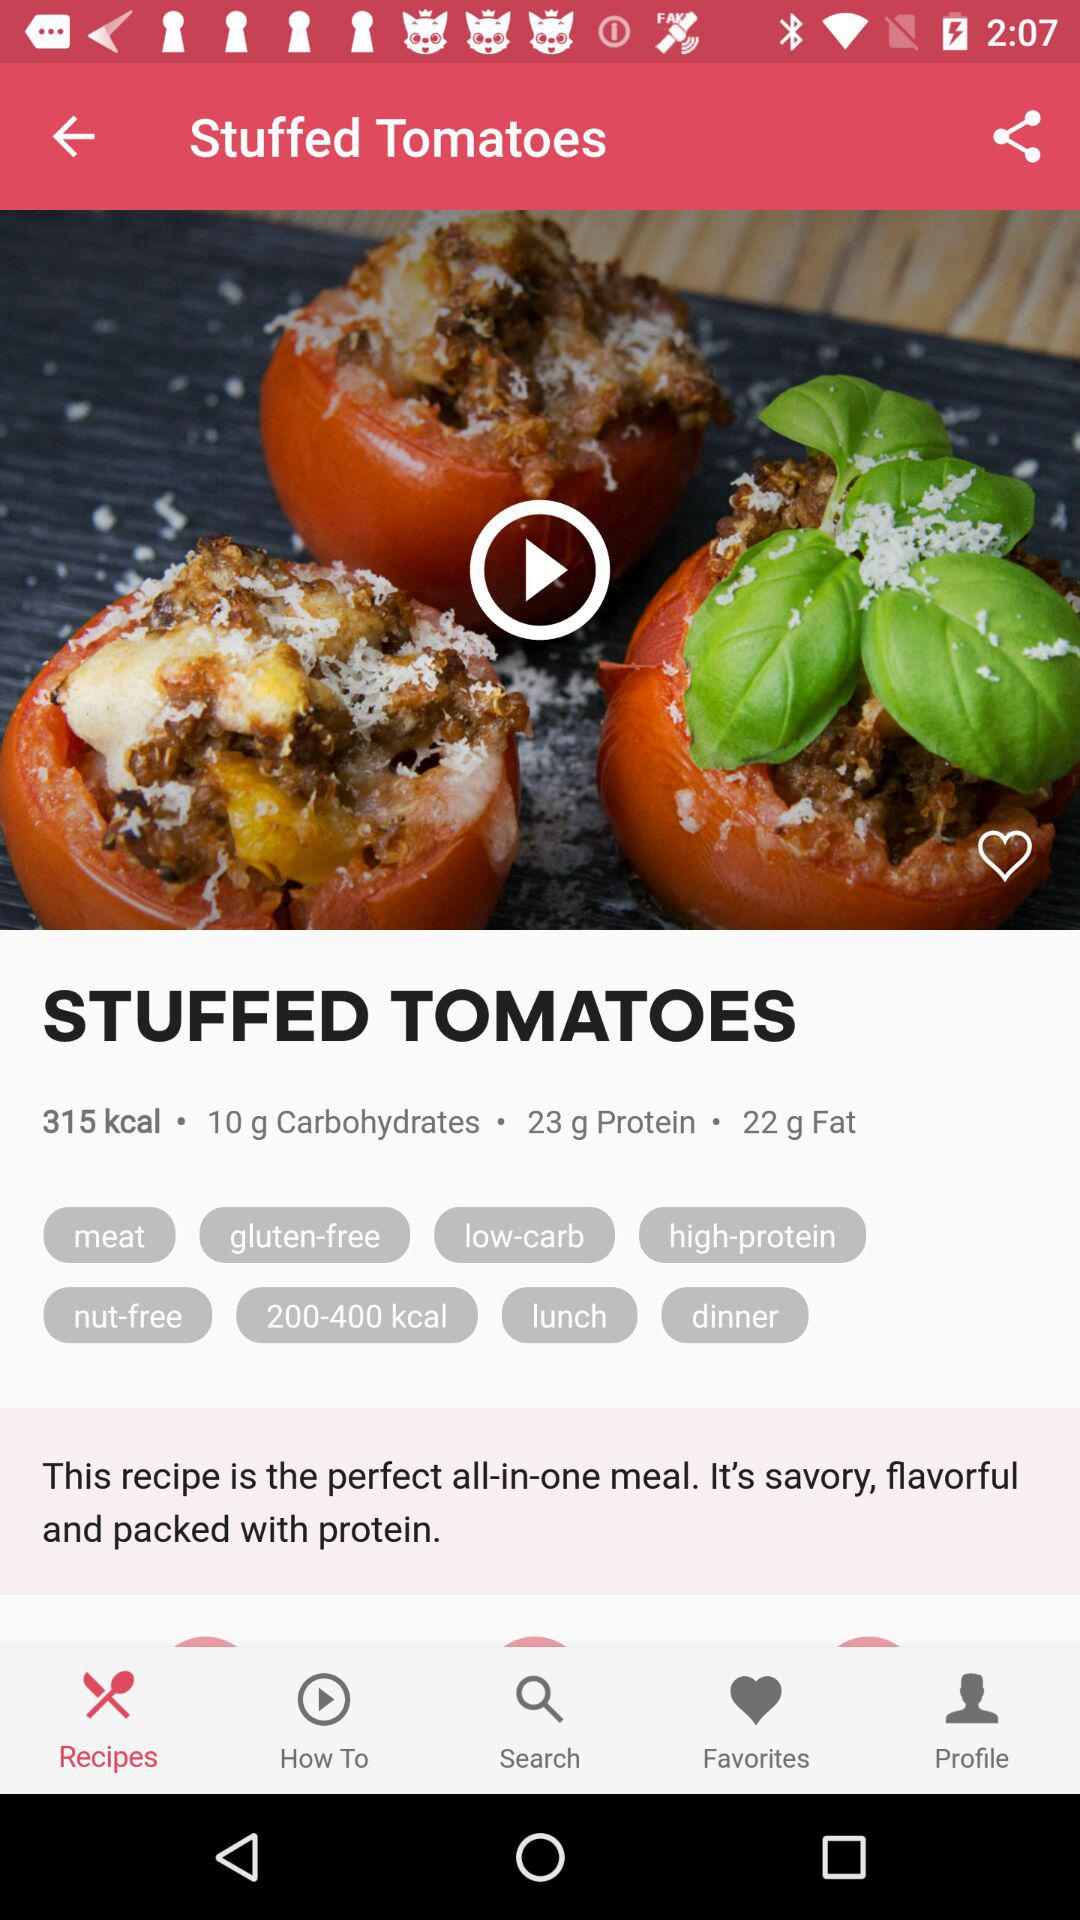Which tab is selected? The selected tab is "Recipes". 